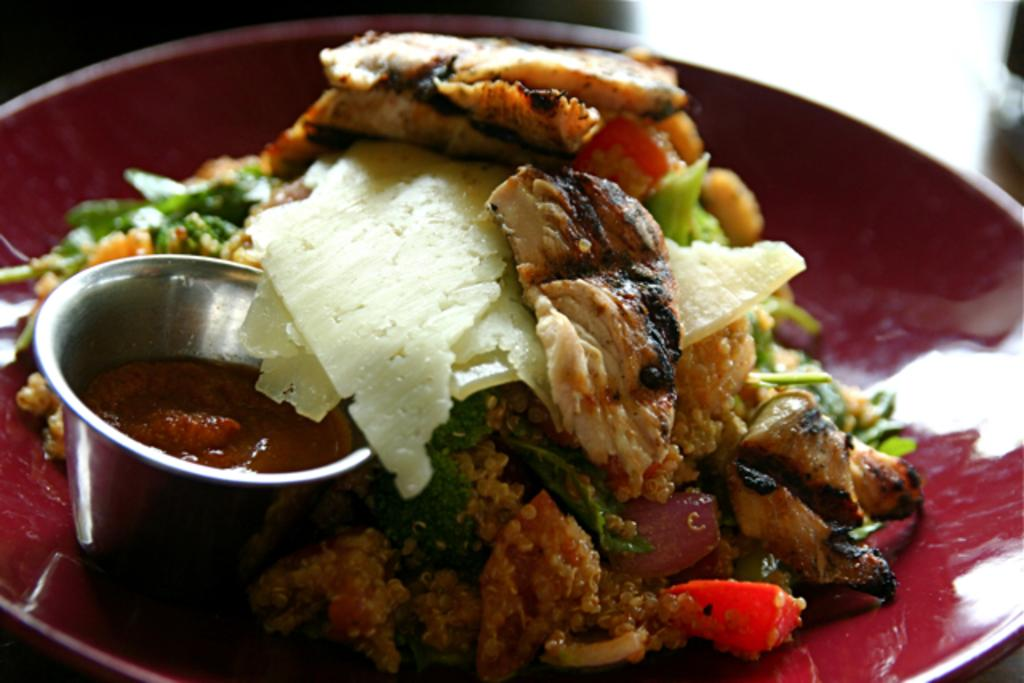What is on the plate in the image? There is food on the plate in the image. What is beside the plate in the image? There is a cup with sauce beside the plate in the image. What type of fan is visible in the image? There is no fan present in the image. What type of agreement is being made in the image? There is no agreement being made in the image; it only shows food on a plate and a cup with sauce beside it. 